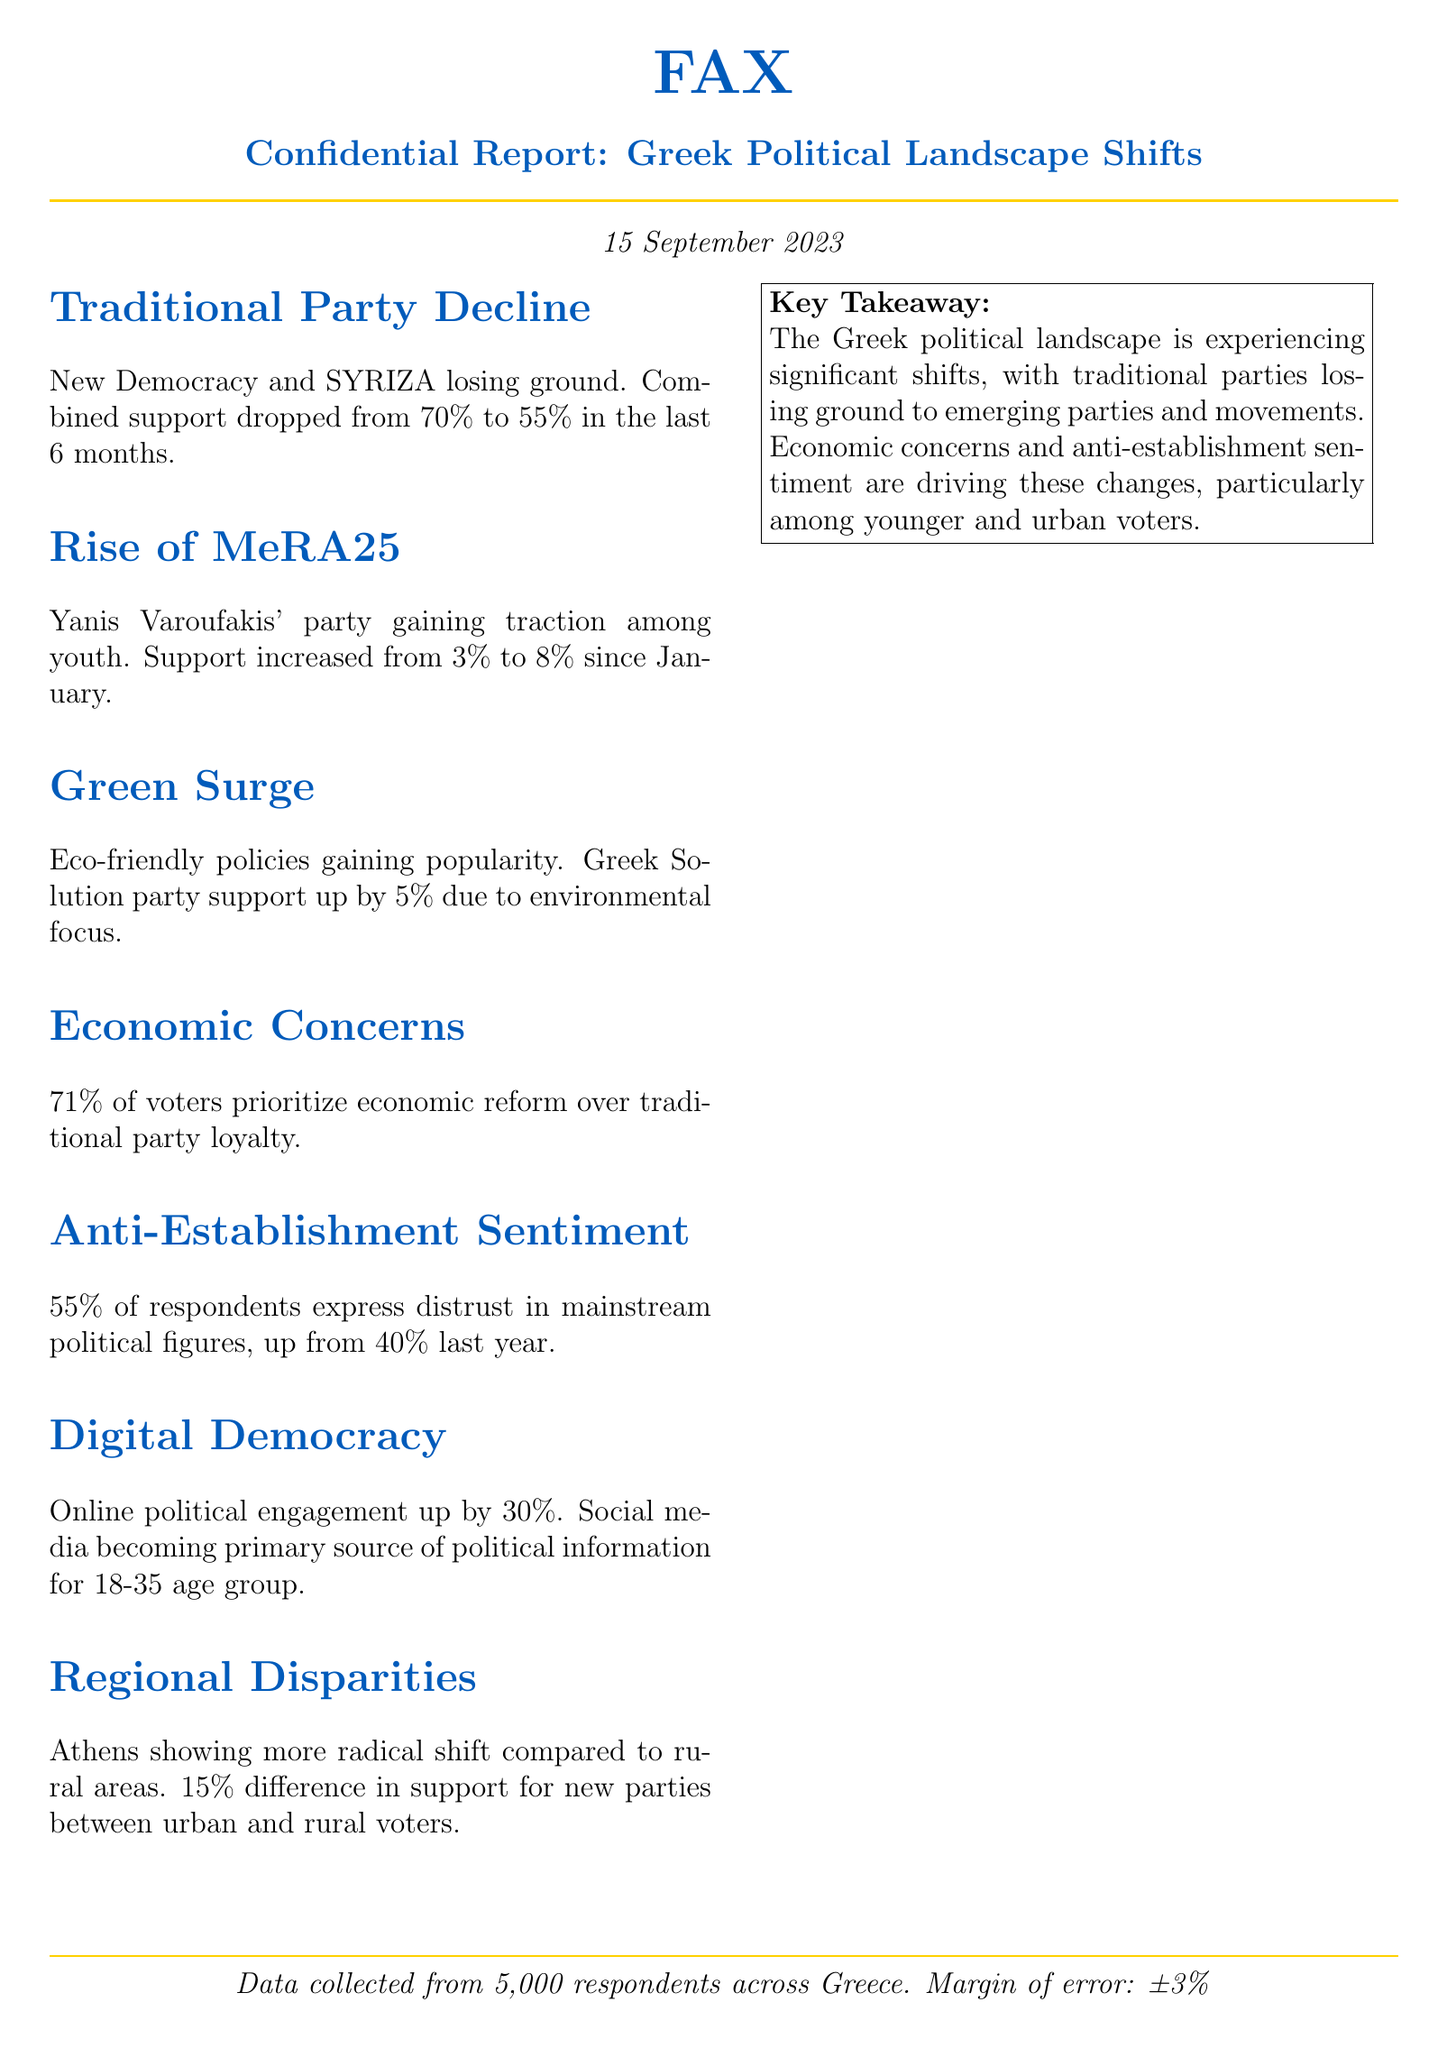what is the date of the report? The document states "15 September 2023" as the date of the report.
Answer: 15 September 2023 what is the combined support percentage for New Democracy and SYRIZA? The report indicates their combined support dropped from 70% to 55%.
Answer: 55% how much did MeRA25's support increase? The document shows that support for MeRA25 increased from 3% to 8%, which is a 5% increase.
Answer: 5% what percentage of voters prioritize economic reform? According to the report, 71% of voters prioritize economic reform over traditional party loyalty.
Answer: 71% what sentiment do 55% of respondents express? The report states that 55% of respondents express distrust in mainstream political figures.
Answer: distrust what is the margin of error in the collected data? The document mentions a margin of error of ±3%.
Answer: ±3% which age group primarily uses social media for political information? The report indicates that social media is becoming a primary source of political information for the 18-35 age group.
Answer: 18-35 age group how much has online political engagement increased? The document states that online political engagement has increased by 30%.
Answer: 30% what is the key takeaway of the report? The report summarizes that the Greek political landscape is experiencing significant shifts with traditional parties losing ground to emerging parties.
Answer: significant shifts 